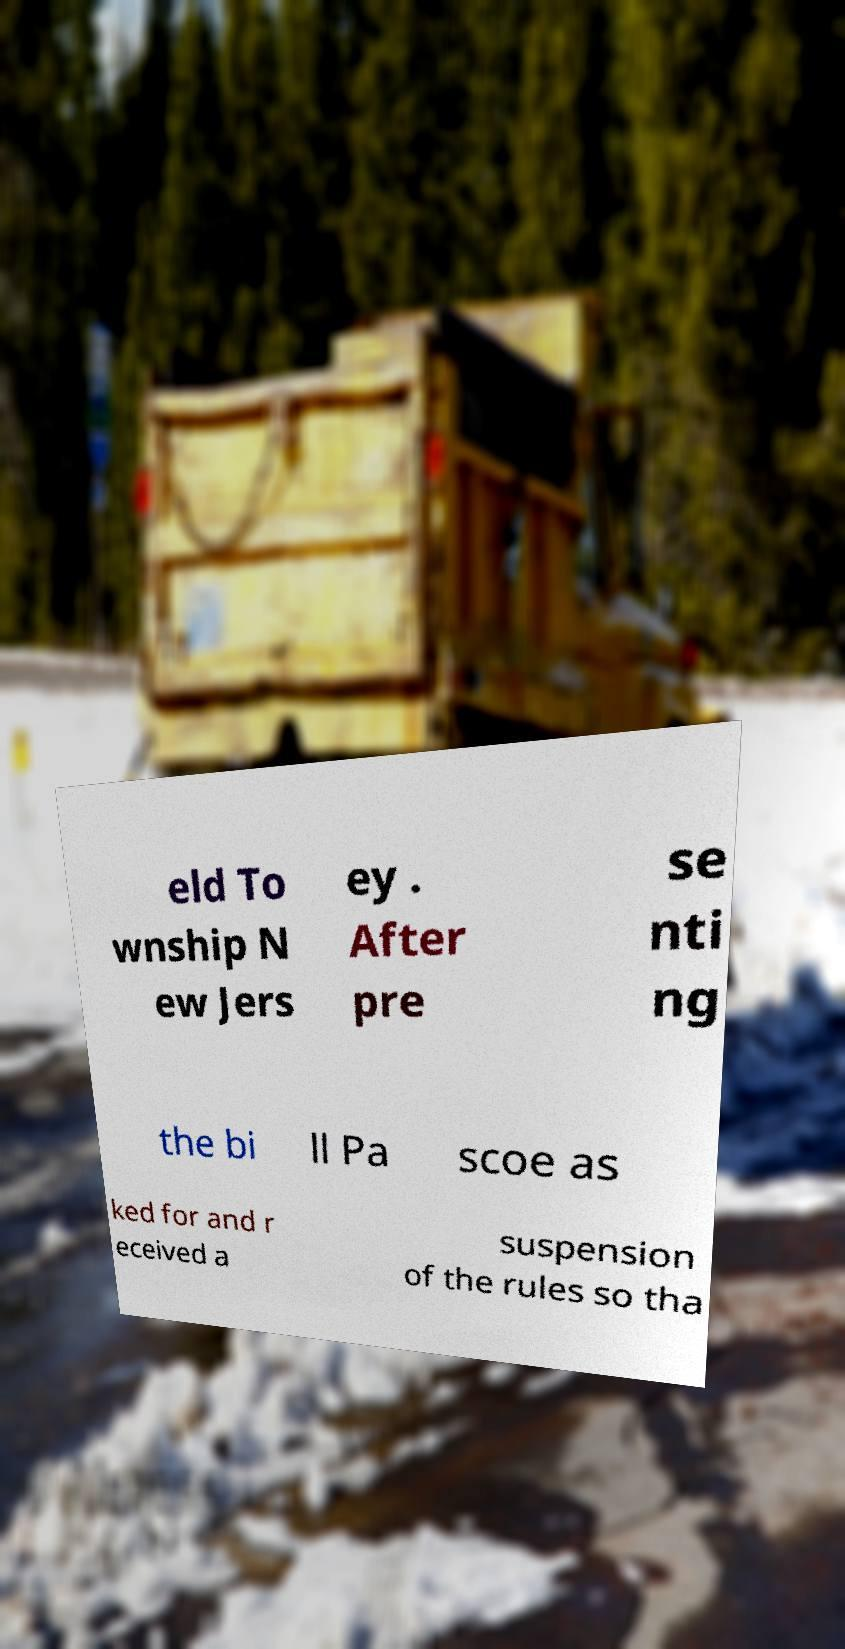Could you assist in decoding the text presented in this image and type it out clearly? eld To wnship N ew Jers ey . After pre se nti ng the bi ll Pa scoe as ked for and r eceived a suspension of the rules so tha 